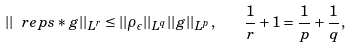<formula> <loc_0><loc_0><loc_500><loc_500>| | \ r e p s * g | | _ { L ^ { r } } \leq | | \rho _ { \epsilon } | | _ { L ^ { q } } | | g | | _ { L ^ { p } } , \quad \frac { 1 } { r } + 1 = \frac { 1 } { p } + \frac { 1 } { q } ,</formula> 